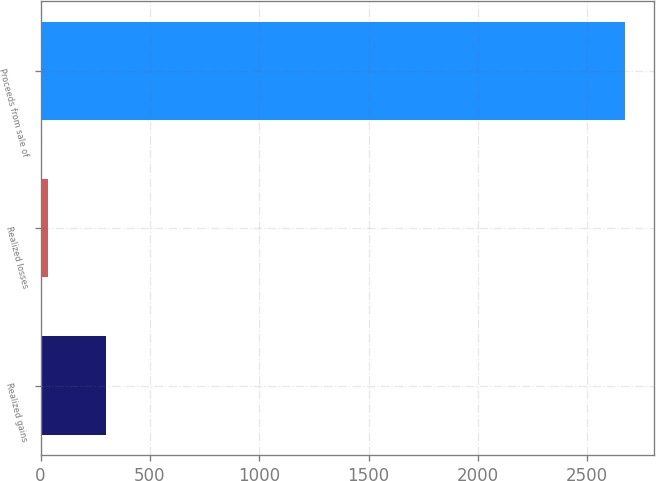Convert chart. <chart><loc_0><loc_0><loc_500><loc_500><bar_chart><fcel>Realized gains<fcel>Realized losses<fcel>Proceeds from sale of<nl><fcel>298.8<fcel>35<fcel>2673<nl></chart> 